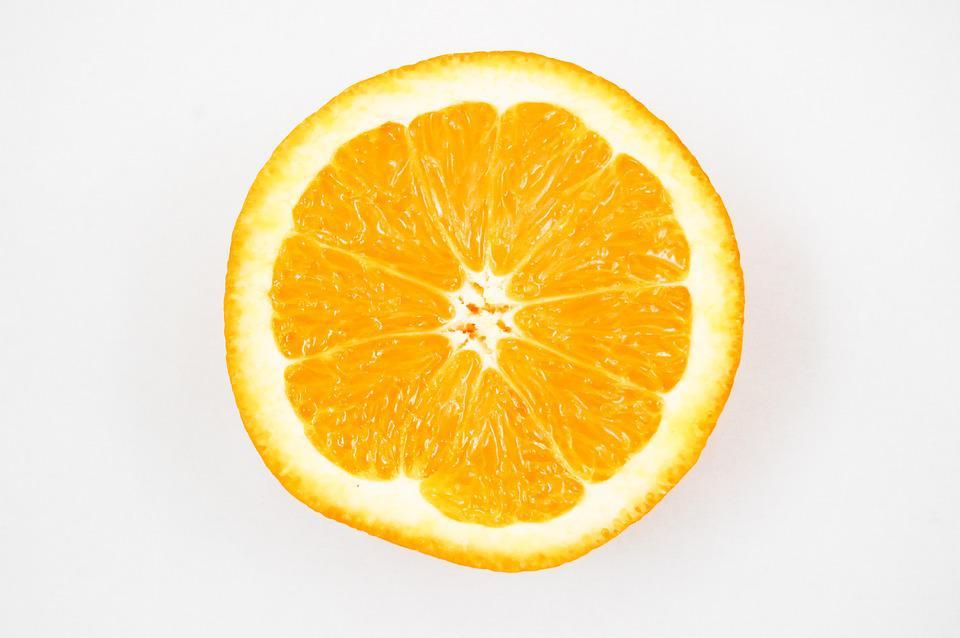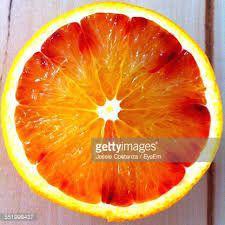The first image is the image on the left, the second image is the image on the right. Analyze the images presented: Is the assertion "There is a whole citrus fruit in one of the images." valid? Answer yes or no. No. The first image is the image on the left, the second image is the image on the right. For the images displayed, is the sentence "Some of the oranges are cut, some are whole." factually correct? Answer yes or no. No. 